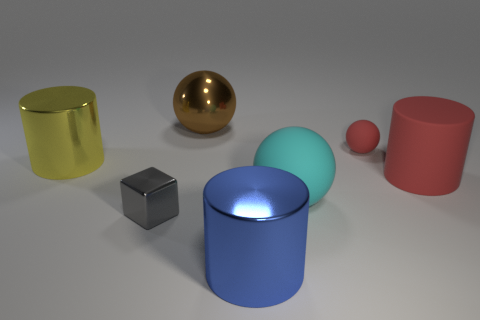Subtract all red rubber cylinders. How many cylinders are left? 2 Subtract all spheres. How many objects are left? 4 Subtract 1 cylinders. How many cylinders are left? 2 Subtract all blue cylinders. How many cylinders are left? 2 Add 2 yellow objects. How many yellow objects exist? 3 Add 1 shiny objects. How many objects exist? 8 Subtract 0 gray cylinders. How many objects are left? 7 Subtract all cyan cylinders. Subtract all green spheres. How many cylinders are left? 3 Subtract all red cylinders. How many brown cubes are left? 0 Subtract all big brown metallic balls. Subtract all big shiny objects. How many objects are left? 3 